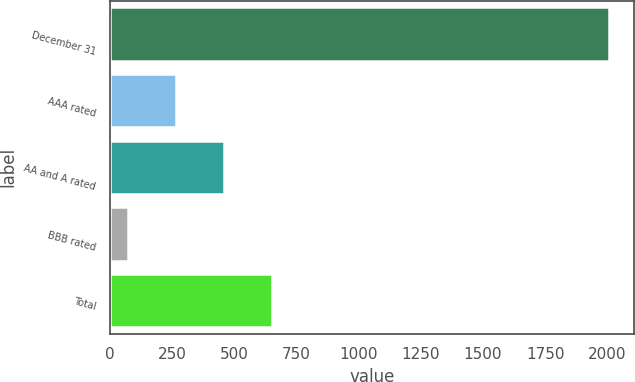<chart> <loc_0><loc_0><loc_500><loc_500><bar_chart><fcel>December 31<fcel>AAA rated<fcel>AA and A rated<fcel>BBB rated<fcel>Total<nl><fcel>2007<fcel>266.4<fcel>459.8<fcel>73<fcel>653.2<nl></chart> 